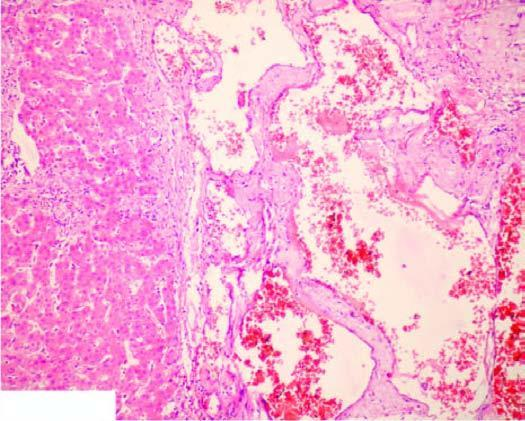s replication of viral dna seen between the cavernous spaces?
Answer the question using a single word or phrase. No 